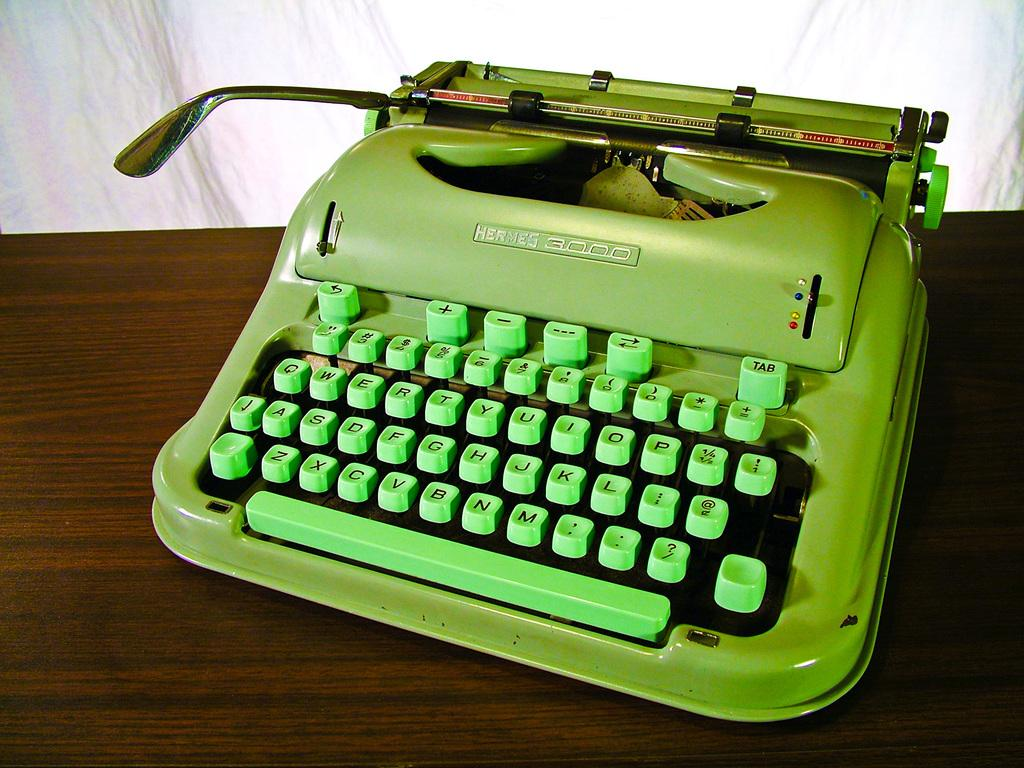<image>
Share a concise interpretation of the image provided. a typewriter that has the name Hermes at the top 